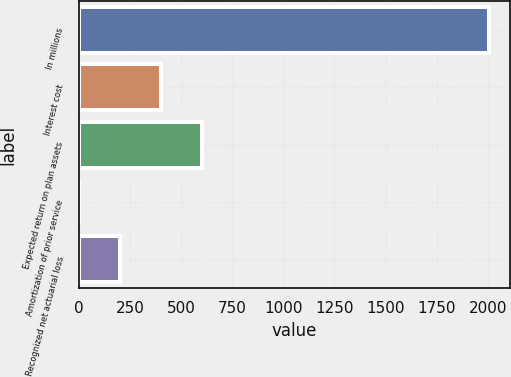<chart> <loc_0><loc_0><loc_500><loc_500><bar_chart><fcel>In millions<fcel>Interest cost<fcel>Expected return on plan assets<fcel>Amortization of prior service<fcel>Recognized net actuarial loss<nl><fcel>2008<fcel>402.4<fcel>603.1<fcel>1<fcel>201.7<nl></chart> 